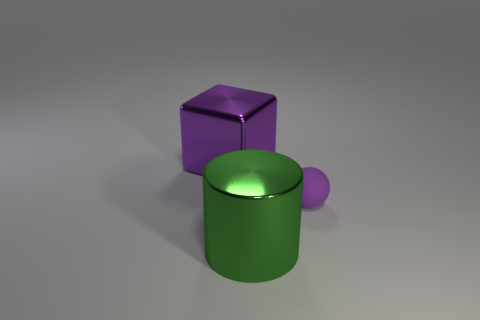There is a object that is behind the small purple object; are there any things that are behind it?
Your answer should be very brief. No. What number of other things are the same color as the tiny thing?
Offer a very short reply. 1. The cube has what size?
Provide a succinct answer. Large. Is there a small blue metal thing?
Ensure brevity in your answer.  No. Is the number of big objects in front of the large purple metallic block greater than the number of matte objects that are left of the purple matte thing?
Give a very brief answer. Yes. There is a thing that is both behind the green object and in front of the purple cube; what is it made of?
Keep it short and to the point. Rubber. Is there any other thing that has the same size as the purple sphere?
Your answer should be compact. No. There is a tiny purple rubber ball; how many tiny purple matte objects are left of it?
Offer a very short reply. 0. Is the size of the thing that is to the left of the green metallic object the same as the ball?
Your response must be concise. No. Are there any other things that have the same shape as the green object?
Provide a short and direct response. No. 